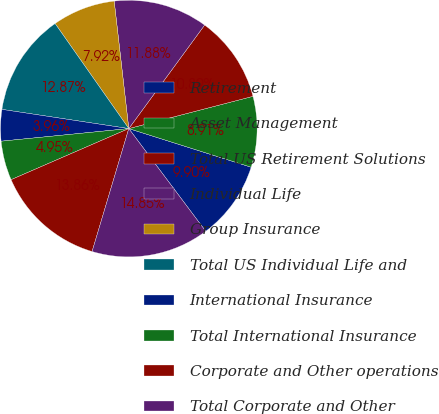<chart> <loc_0><loc_0><loc_500><loc_500><pie_chart><fcel>Retirement<fcel>Asset Management<fcel>Total US Retirement Solutions<fcel>Individual Life<fcel>Group Insurance<fcel>Total US Individual Life and<fcel>International Insurance<fcel>Total International Insurance<fcel>Corporate and Other operations<fcel>Total Corporate and Other<nl><fcel>9.9%<fcel>8.91%<fcel>10.89%<fcel>11.88%<fcel>7.92%<fcel>12.87%<fcel>3.96%<fcel>4.95%<fcel>13.86%<fcel>14.85%<nl></chart> 